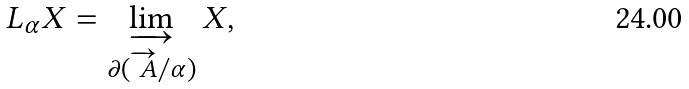Convert formula to latex. <formula><loc_0><loc_0><loc_500><loc_500>L _ { \alpha } X = \varinjlim _ { \partial ( \overrightarrow { \ A } / \alpha ) } X ,</formula> 